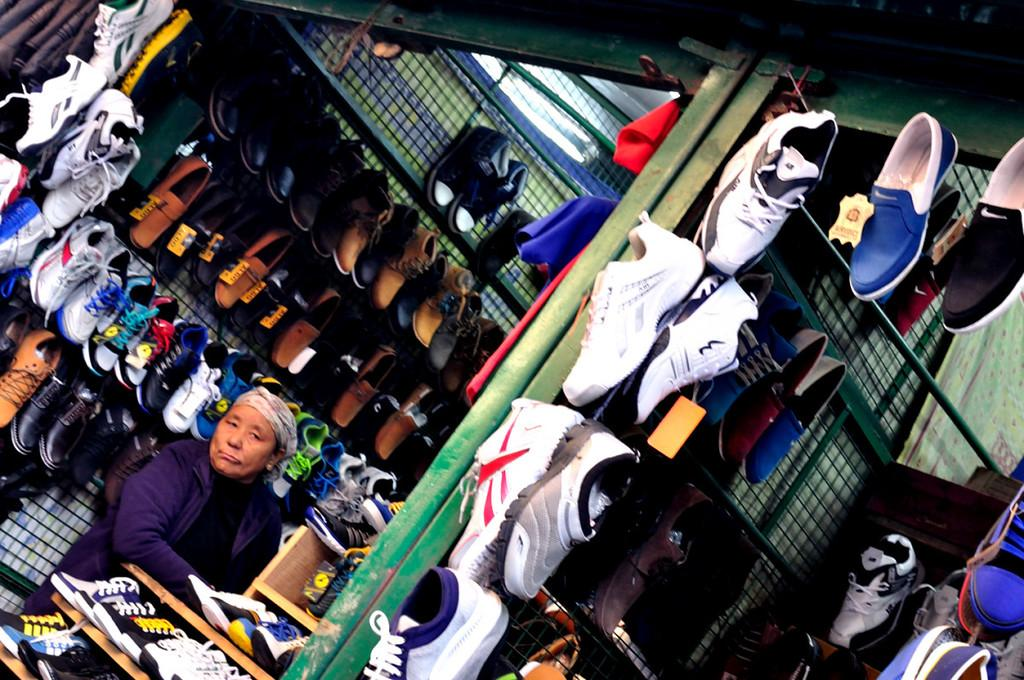What is the main subject of the image? The main subject of the image is shoes hanging on welded meshes and shoes on racks. What type of material is used for the meshes and racks? The meshes and racks are made of metal, as a metal object is visible in the image. Can you describe the person in the image? There is a person in the image, but no specific details about their appearance or actions are provided. What is present at the top of the image? Socks and shutters are visible at the top of the image. What type of punishment is being administered to the cats in the image? There are no cats present in the image, so no punishment is being administered to them. 